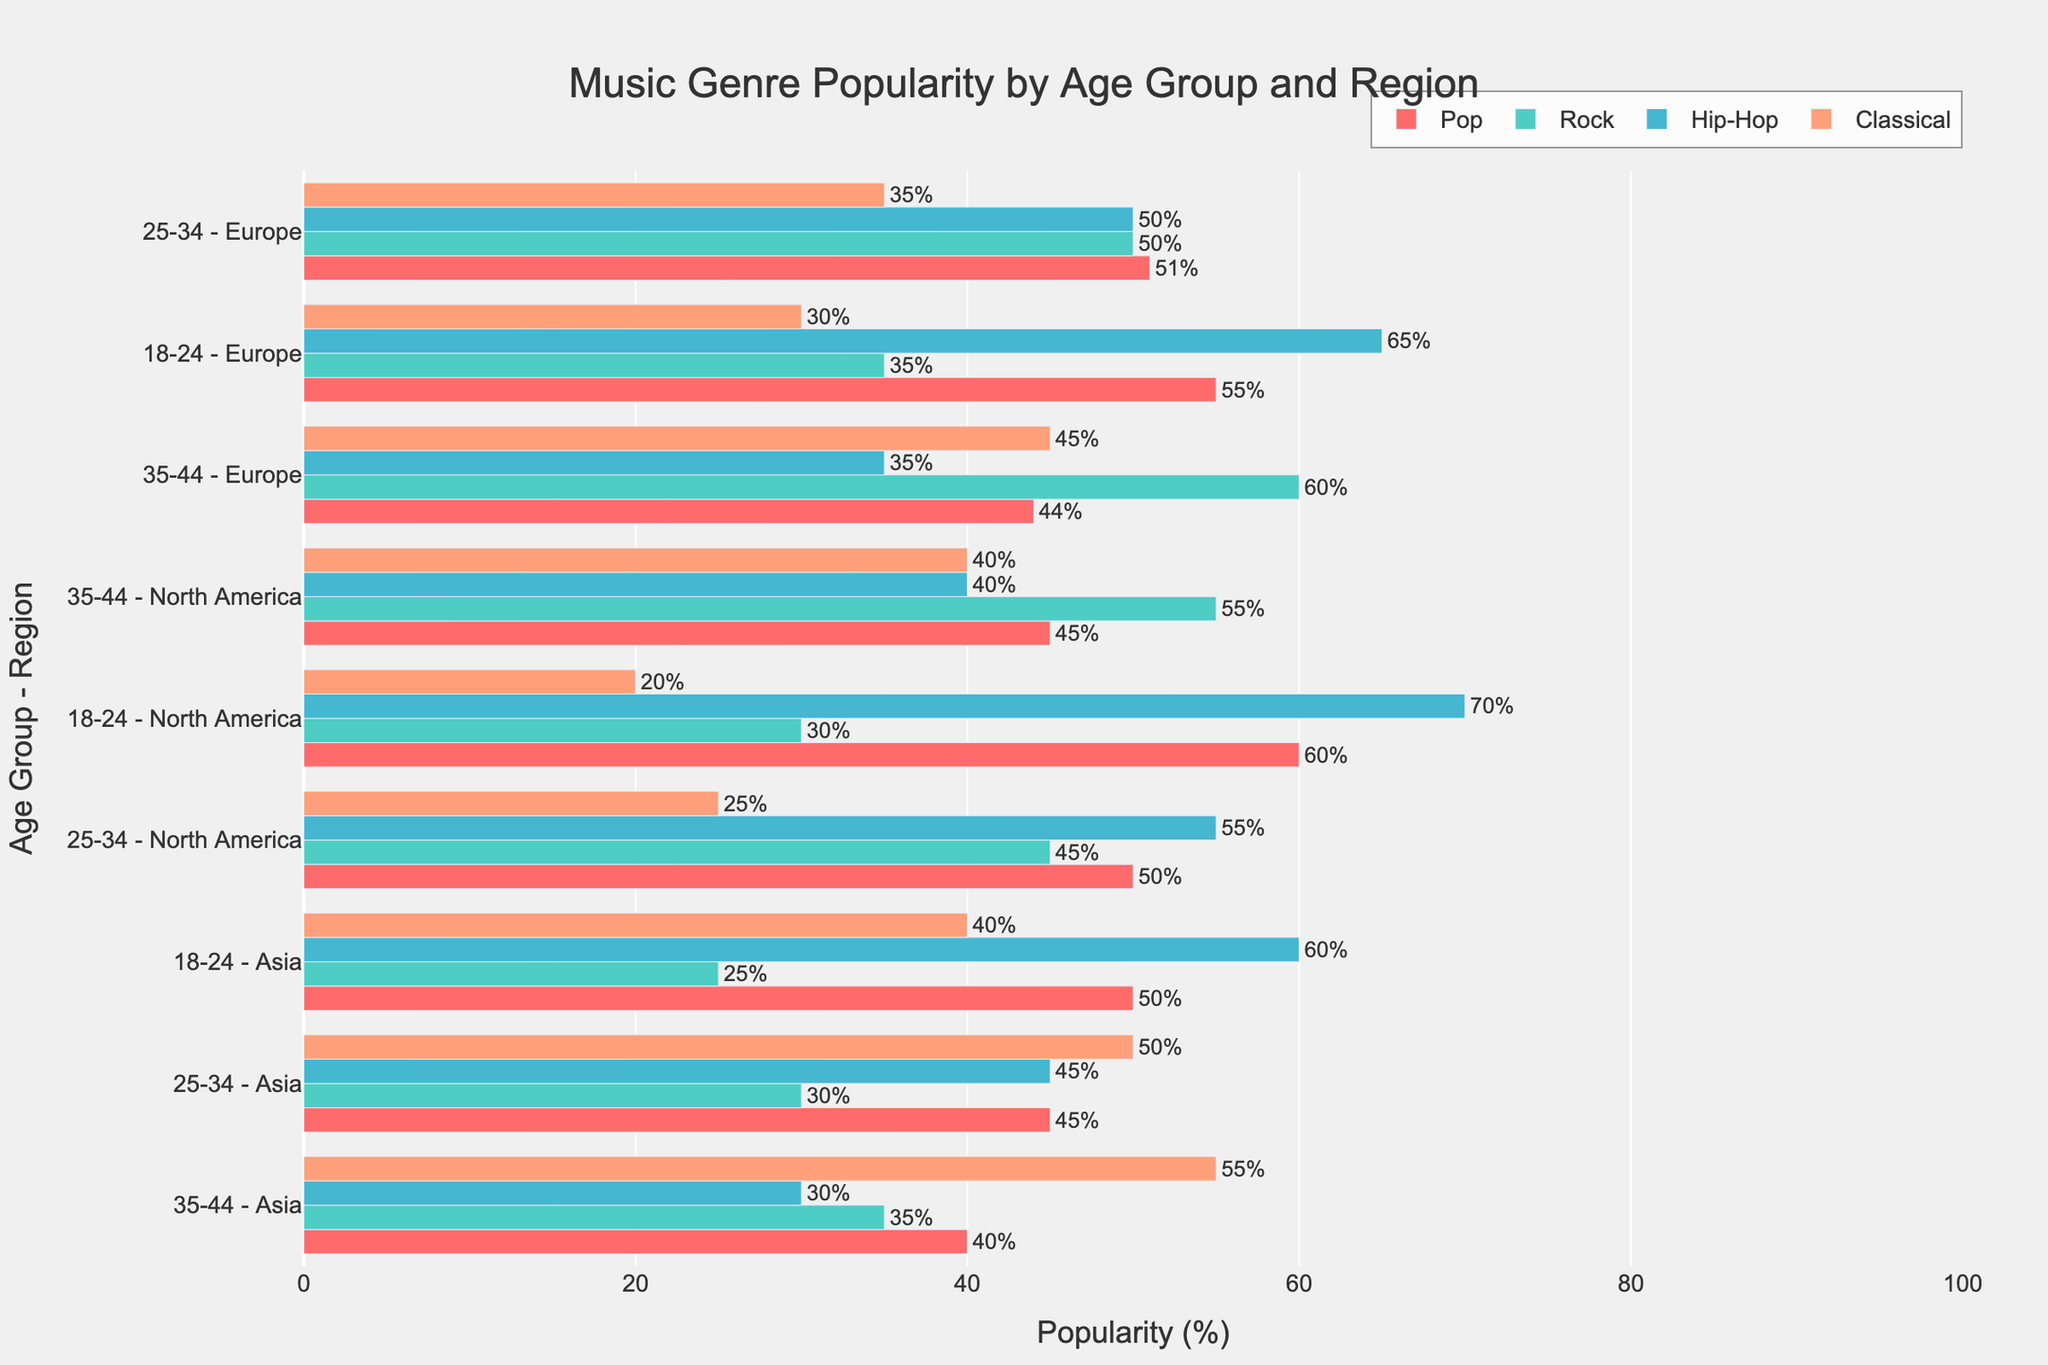What is the most popular genre among the 18-24 age group in North America? Look at the bars corresponding to the 18-24 age group in North America across different genres. The Hip-Hop genre has the highest bar with a popularity of 70%.
Answer: Hip-Hop Which age group and region combination has the highest popularity for Classical music? Observe the bars for Classical music across all age groups and regions. The 35-44 age group in Asia has the highest popularity with a value of 55%.
Answer: 35-44 in Asia Among the 25-34 age group in Europe, which genre has the lowest popularity? Examine the bars for the 25-34 age group in Europe. Classical music has the lowest popularity with a value of 35%.
Answer: Classical What is the difference in popularity between Hip-Hop and Rock for the 18-24 age group in Europe? Identify the popularity values for Hip-Hop and Rock in the 18-24 age group in Europe, which are 65% and 35%, respectively. The difference is 65 - 35 = 30%.
Answer: 30% How does the popularity of Pop in the 35-44 age group in North America compare to its popularity in Europe? Compare the bars for Pop in the 35-44 age group in North America and Europe. The popularity in North America is 45%, while in Europe it is 44%. North America has a 1% higher popularity.
Answer: North America is 1% higher What is the combined popularity of Rock and Hip-Hop in the 35-44 age group in North America? Look at the popularity values for Rock and Hip-Hop in the 35-44 age group in North America. Rock is 55% and Hip-Hop is 40%. The combined popularity is 55 + 40 = 95%.
Answer: 95% Among the 18-24 age group, which genre shows the highest popularity in Asia? Check the bars for the 18-24 age group in Asia across different genres. Classical music has the highest popularity with 40%.
Answer: Classical How much more popular is Hip-Hop than Pop in the 25-34 age group in North America? Compare the popularity values for Hip-Hop and Pop in the 25-34 age group in North America. Hip-Hop has 55% while Pop has 50%. The difference is 55 - 50 = 5%.
Answer: 5% Which genre has the widest range of popularity values across different regions for the 18-24 age group? Evaluate the range of popularity values for each genre in the 18-24 age group across different regions. Hip-Hop ranges from 60% to 70%, Pop from 50% to 60%, Rock from 25% to 35%, and Classical from 20% to 40%. Classical has the widest range (20%).
Answer: Classical 